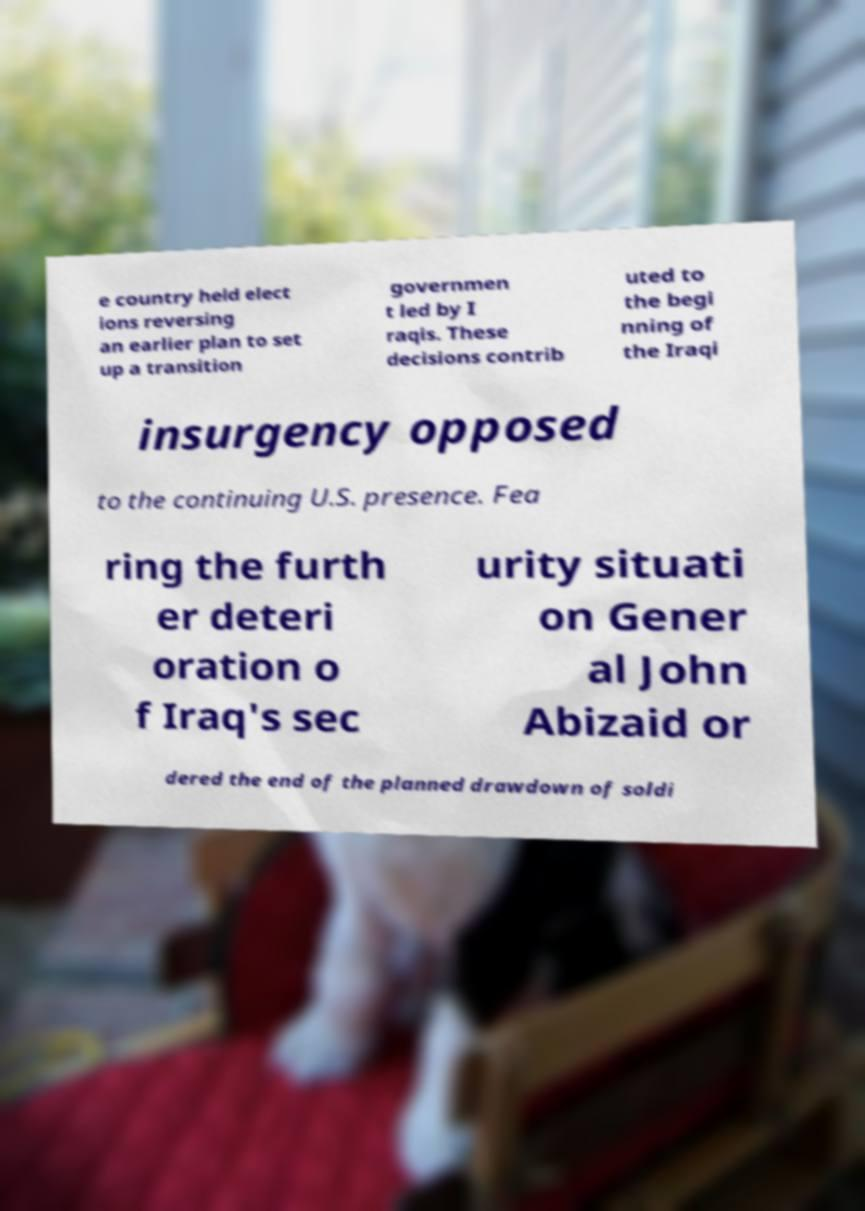Please identify and transcribe the text found in this image. e country held elect ions reversing an earlier plan to set up a transition governmen t led by I raqis. These decisions contrib uted to the begi nning of the Iraqi insurgency opposed to the continuing U.S. presence. Fea ring the furth er deteri oration o f Iraq's sec urity situati on Gener al John Abizaid or dered the end of the planned drawdown of soldi 